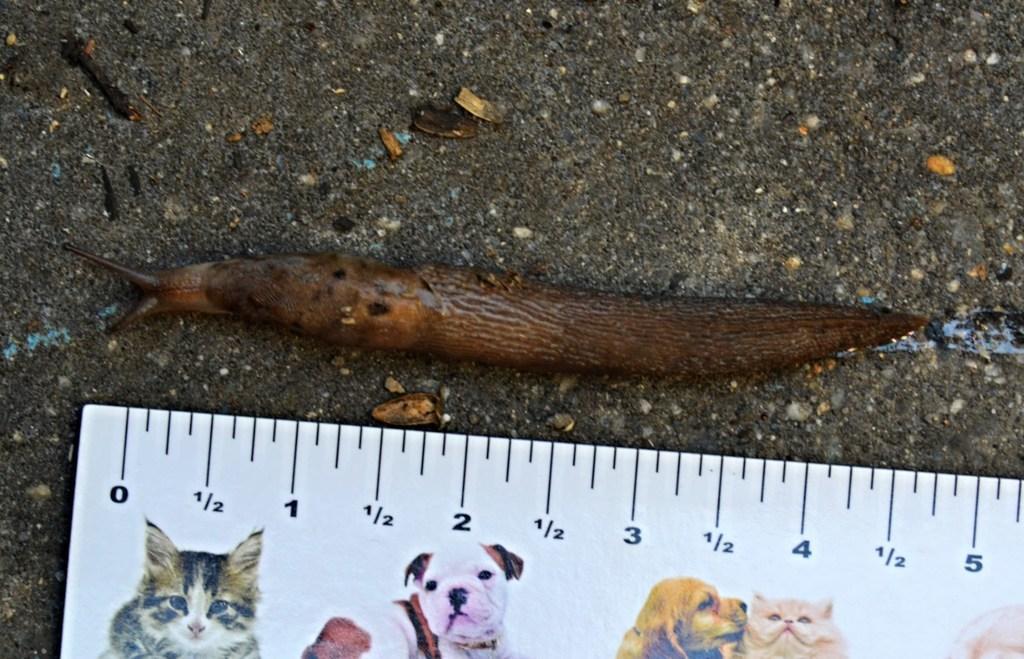Can you describe this image briefly? In this picture I can see there is a snail and there is a scale are also there are some pictures of cat and dog on the scale. 